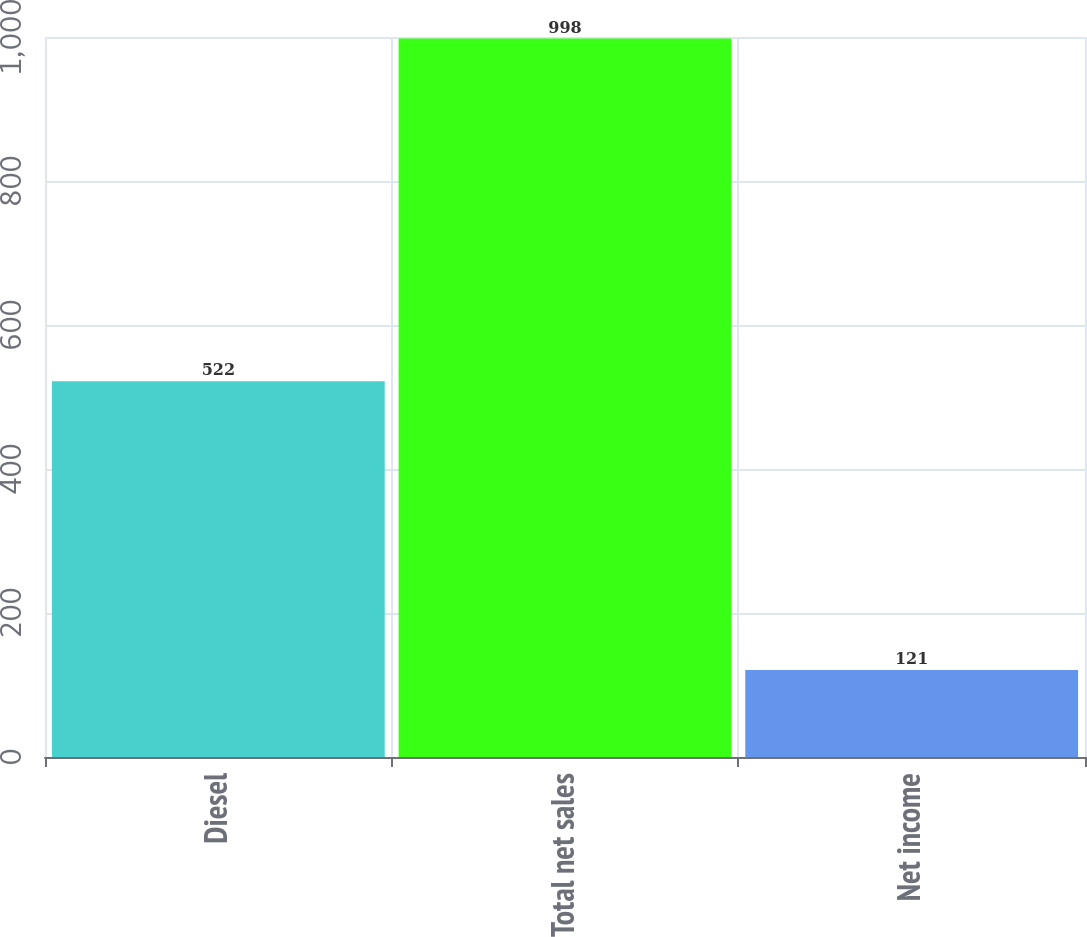<chart> <loc_0><loc_0><loc_500><loc_500><bar_chart><fcel>Diesel<fcel>Total net sales<fcel>Net income<nl><fcel>522<fcel>998<fcel>121<nl></chart> 